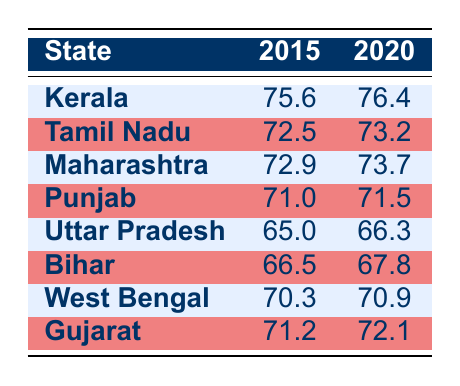What was the life expectancy of Kerala in 2020? According to the table, the life expectancy for Kerala in the year 2020 is 76.4. This value is listed under the 2020 column for the state of Kerala.
Answer: 76.4 Which state had the highest life expectancy in 2015? Looking through the table for the year 2015, Kerala has the highest life expectancy at 75.6, compared to other states listed.
Answer: Kerala What is the difference in life expectancy for Tamil Nadu from 2015 to 2020? For Tamil Nadu, the life expectancy in 2015 is 72.5 and in 2020 it is 73.2. The difference is 73.2 - 72.5 = 0.7.
Answer: 0.7 Is it true that Uttar Pradesh had a life expectancy of over 66 in 2020? The table shows that in 2020, the life expectancy for Uttar Pradesh is 66.3, which is not over 66. Therefore, the statement is false.
Answer: No What was the average life expectancy across all listed states in 2020? To find the average for all states in 2020, sum their life expectancies: (76.4 + 73.2 + 73.7 + 71.5 + 66.3 + 67.8 + 70.9 + 72.1) = 501. The average is 501 divided by 8 states = 62.625.
Answer: 62.625 Which state had the lowest life expectancy in both 2015 and 2020? From the table, Uttar Pradesh has the lowest life expectancy in both years: 65.0 in 2015 and 66.3 in 2020. Comparing this against other states confirms this observation.
Answer: Uttar Pradesh What was the percentage increase in life expectancy for Bihar from 2015 to 2020? Bihar's life expectancy increased from 66.5 in 2015 to 67.8 in 2020, which is a difference of 67.8 - 66.5 = 1.3. To calculate the percentage increase, (1.3 / 66.5) * 100 ≈ 1.95%.
Answer: 1.95% Did any state experience a decrease in life expectancy from 2015 to 2020? According to the table, all states show an increase in life expectancy from 2015 to 2020. Therefore, the answer is no; no state experienced a decrease.
Answer: No 